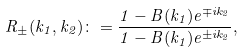<formula> <loc_0><loc_0><loc_500><loc_500>R _ { \pm } ( k _ { 1 } , k _ { 2 } ) \colon = \frac { 1 - B ( k _ { 1 } ) e ^ { \mp i k _ { 2 } } } { 1 - B ( k _ { 1 } ) e ^ { \pm i k _ { 2 } } } ,</formula> 